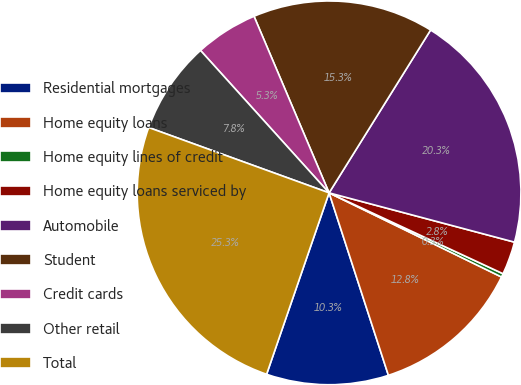<chart> <loc_0><loc_0><loc_500><loc_500><pie_chart><fcel>Residential mortgages<fcel>Home equity loans<fcel>Home equity lines of credit<fcel>Home equity loans serviced by<fcel>Automobile<fcel>Student<fcel>Credit cards<fcel>Other retail<fcel>Total<nl><fcel>10.28%<fcel>12.77%<fcel>0.3%<fcel>2.79%<fcel>20.26%<fcel>15.27%<fcel>5.29%<fcel>7.78%<fcel>25.25%<nl></chart> 